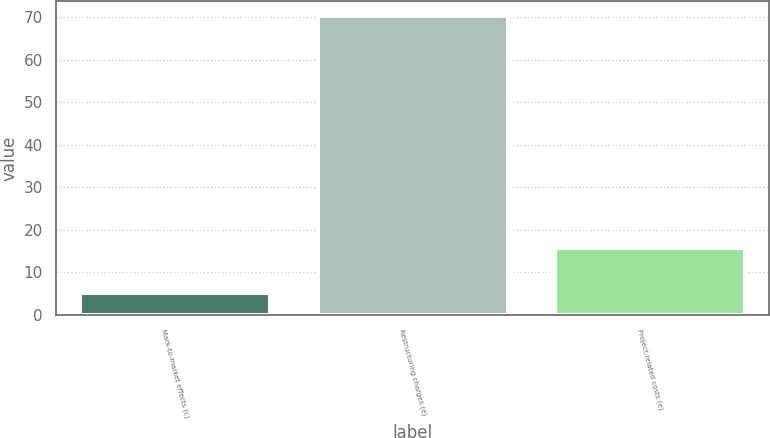Convert chart. <chart><loc_0><loc_0><loc_500><loc_500><bar_chart><fcel>Mark-to-market effects (c)<fcel>Restructuring charges (e)<fcel>Project-related costs (e)<nl><fcel>5.1<fcel>70.2<fcel>15.7<nl></chart> 